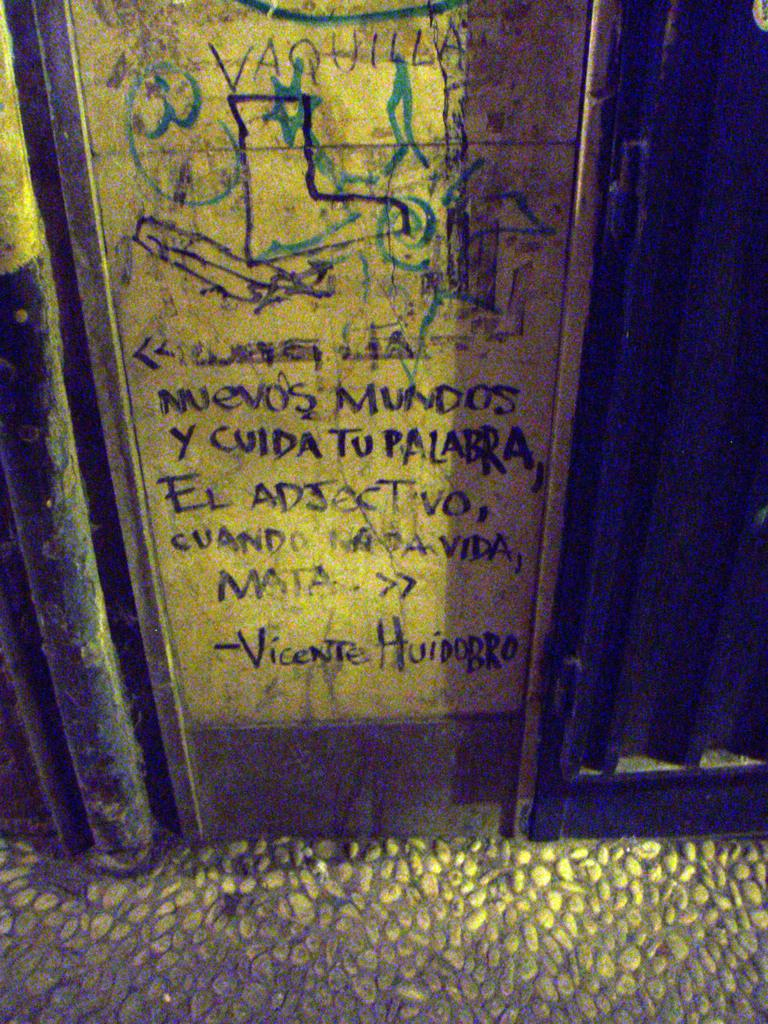<image>
Write a terse but informative summary of the picture. Writing that is carved on a door by Vicente Huidobro. 